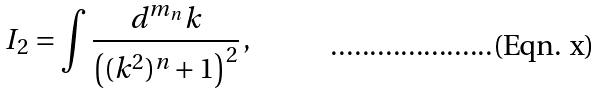<formula> <loc_0><loc_0><loc_500><loc_500>I _ { 2 } = \int \frac { d ^ { m _ { n } } k } { \left ( ( k ^ { 2 } ) ^ { n } + 1 \right ) ^ { 2 } } \, ,</formula> 